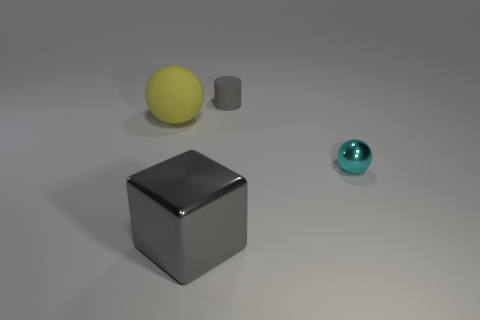How would you describe the lighting in this scene? The lighting in the scene is soft and diffuse, casting gentle shadows and giving the objects a slightly three-dimensional look without any harsh contrasts. 